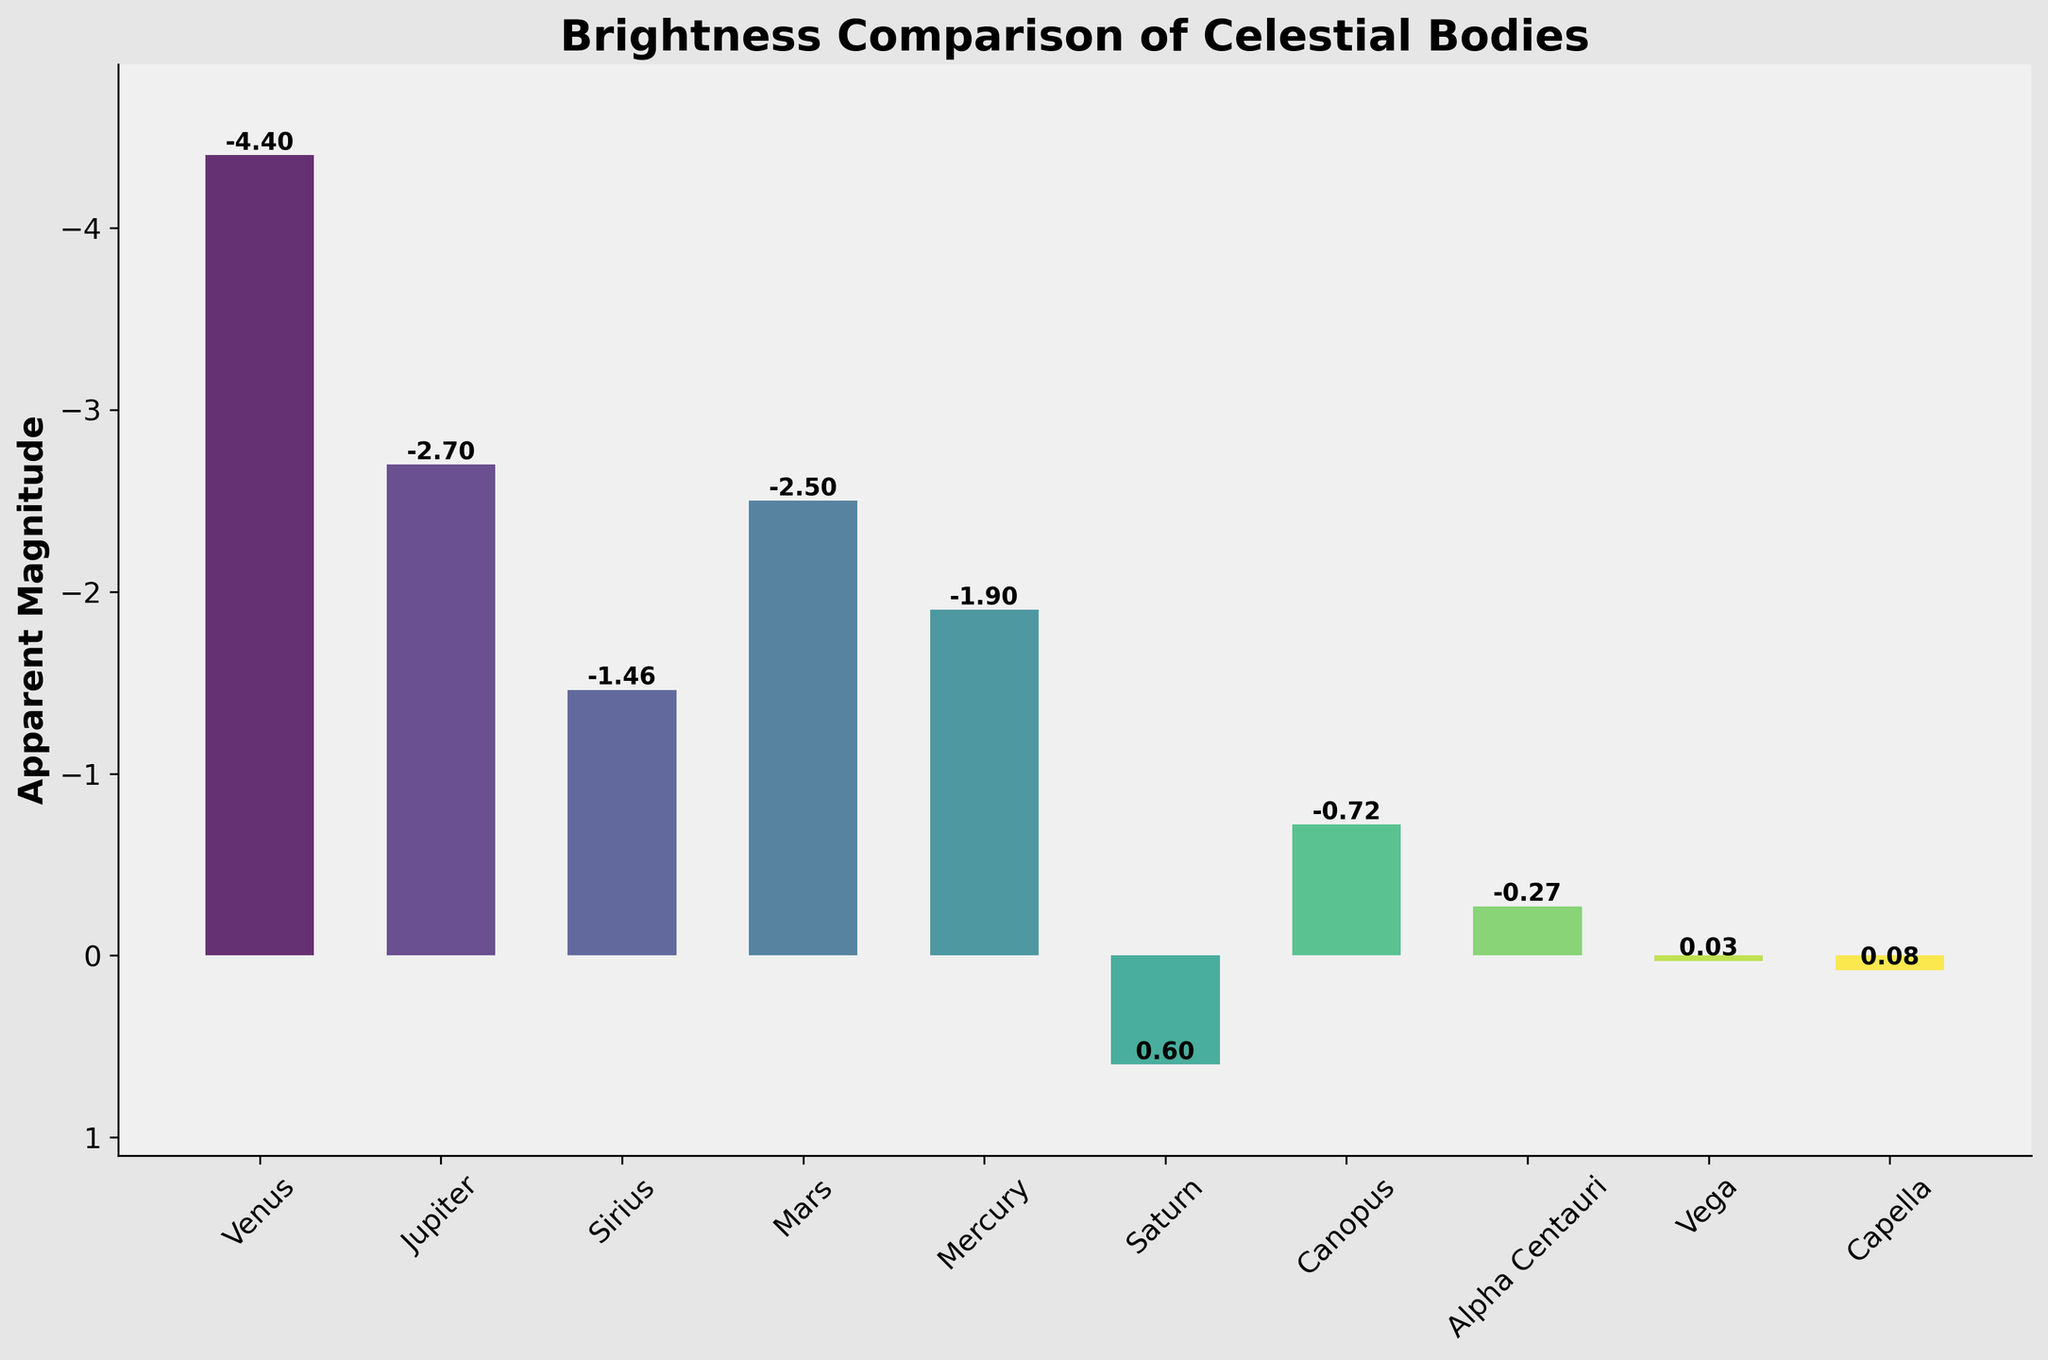Which celestial body has the highest apparent magnitude in the chart? The celestial body with the highest apparent magnitude will be represented by the tallest bar on the inverted y-axis because higher apparent magnitude values are less negative. Find the bar located closest to the bottom of the chart.
Answer: Saturn What is the difference in apparent magnitude between Venus and Jupiter? Locate the bars for Venus and Jupiter, then subtract the apparent magnitude of Jupiter (-2.7) from that of Venus (-4.4). Use the formula: difference = (-4.4) - (-2.7).
Answer: -1.7 Which object is brighter, Sirius or Mars, and by what margin? Compare the heights of the bars for Sirius and Mars. Since a lower apparent magnitude indicates higher brightness, find the difference in their magnitudes: (-1.46) - (-2.5) = 1.04. Since Mars has a lower magnitude, it is brighter.
Answer: Mars, 1.04 Arrange the celestial bodies in order of brightness from least to most. Since the chart uses the inverted y-axis to display apparent magnitudes, read the values starting from the top (less negative, hence less bright) downward (more negative, hence more bright): Saturn, Capella, Vega, Alpha Centauri, Canopus, Mercury, Sirius, Mars, Jupiter, Venus.
Answer: Saturn, Capella, Vega, Alpha Centauri, Canopus, Mercury, Sirius, Mars, Jupiter, Venus What is the average apparent magnitude of the top five brightest celestial bodies? First, identify the top five brightest bodies by looking for the bars with the most negative values: Venus (-4.4), Jupiter (-2.7), Mars (-2.5), Sirius (-1.46), Mercury (-1.9). Then, calculate their average: (-4.4 + -2.7 + -2.5 + -1.46 + -1.9) / 5.
Answer: -2.592 Which celestial body is found to have an apparent magnitude closest to zero? Locate the bar whose height corresponds to an apparent magnitude value near zero in the chart: Vega with an apparent magnitude of 0.03.
Answer: Vega If one of the celestial bodies' apparent magnitude changes by +0.5, which one would equal to the apparent magnitude of Capella? Locate Capella on the chart (apparent magnitude 0.08). Find any celestial body whose magnitude, when increased by 0.5, equals Capella: Alpha Centauri (-0.27 + 0.5 = 0.23), which is not equal to Capella. None of the bodies will exactly match Capella's magnitude.
Answer: None Is Canopus brighter than Mercury? Compare the bars for Canopus and Mercury. Canopus has an apparent magnitude of -0.72 and Mercury -1.9; since -1.9 is more negative, Mercury is brighter.
Answer: No By how much would the magnitude of Alpha Centauri need to change to match the magnitude of Sirius? Compute the difference in apparent magnitudes between Alpha Centauri (-0.27) and Sirius (-1.46): (-1.46 - -0.27) = -1.19. Alpha Centauri's apparent magnitude would need to decrease by 1.19 to match Sirius.
Answer: -1.19 